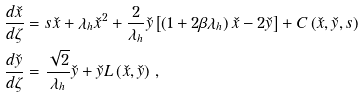Convert formula to latex. <formula><loc_0><loc_0><loc_500><loc_500>\frac { d \check { x } } { d \zeta } & = s \check { x } + \lambda _ { h } \check { x } ^ { 2 } + \frac { 2 } { \lambda _ { h } } \check { y } \left [ \left ( 1 + 2 \beta \lambda _ { h } \right ) \check { x } - 2 \check { y } \right ] + C \left ( \check { x } , \check { y } , s \right ) \\ \frac { d \check { y } } { d \zeta } & = \frac { \sqrt { 2 } } { \lambda _ { h } } \check { y } + \check { y } L \left ( \check { x } , \check { y } \right ) \, ,</formula> 